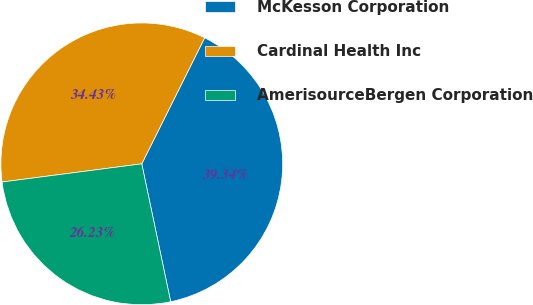<chart> <loc_0><loc_0><loc_500><loc_500><pie_chart><fcel>McKesson Corporation<fcel>Cardinal Health Inc<fcel>AmerisourceBergen Corporation<nl><fcel>39.34%<fcel>34.43%<fcel>26.23%<nl></chart> 